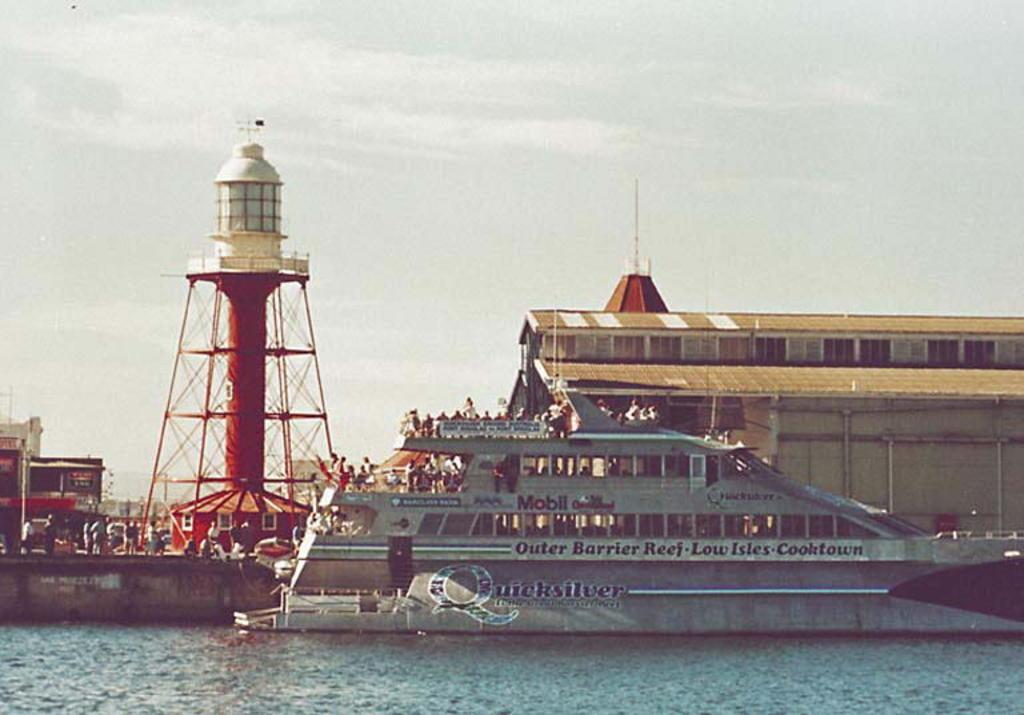<image>
Present a compact description of the photo's key features. A boat with Quicksilver on the side is in the water. 